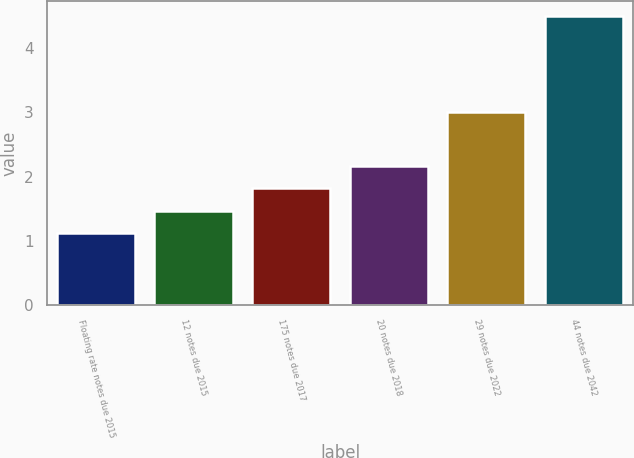Convert chart to OTSL. <chart><loc_0><loc_0><loc_500><loc_500><bar_chart><fcel>Floating rate notes due 2015<fcel>12 notes due 2015<fcel>175 notes due 2017<fcel>20 notes due 2018<fcel>29 notes due 2022<fcel>44 notes due 2042<nl><fcel>1.13<fcel>1.47<fcel>1.82<fcel>2.16<fcel>3.01<fcel>4.5<nl></chart> 